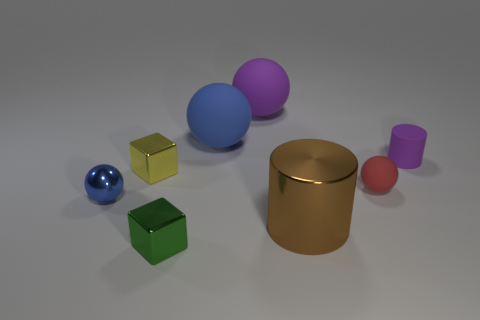Is there another object that has the same shape as the yellow object? Yes, the yellow cube shares the same geometrical shape with the green cube, both demonstrating the properties of a cube, having six faces, twelve edges, and eight vertices. 